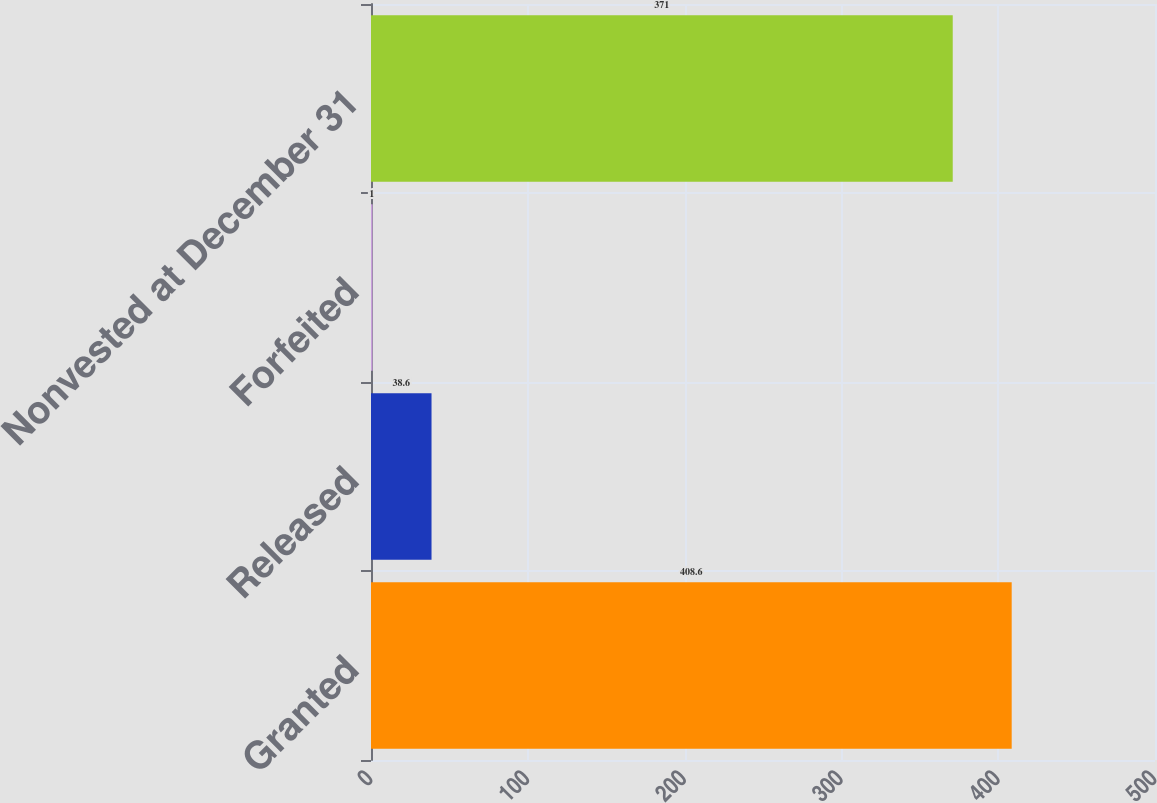Convert chart. <chart><loc_0><loc_0><loc_500><loc_500><bar_chart><fcel>Granted<fcel>Released<fcel>Forfeited<fcel>Nonvested at December 31<nl><fcel>408.6<fcel>38.6<fcel>1<fcel>371<nl></chart> 